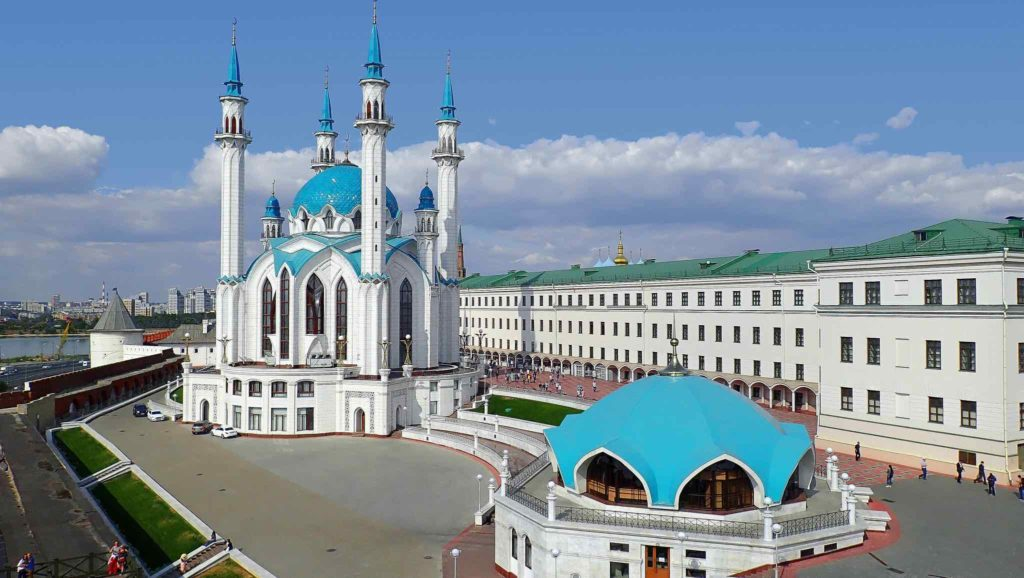What's happening in the scene? The image provides a splendid aerial view of the Kazan Kremlin, a historic fortress in Kazan, Russia, that dates back to the 16th century. Prominently featured is the stunning Kul Sharif Mosque, with its bright blue domes and soaring minarets offering a modern touch amidst the ancient citadel. Next to it stands the elegant Presidential Palace, distinguishable by its classic green roof. These structures are encompassed by robust red brick walls, exemplifying traditional Russian architectural prowess. The lush green surroundings and the clear blue sky add a vivid contrast, highlighting the site's blend of historical significance and natural beauty. This scene not only captures the architectural splendor but also reflects the cultural harmony within Kazan, illustrating a landmark where history and modernity coexist gracefully. 